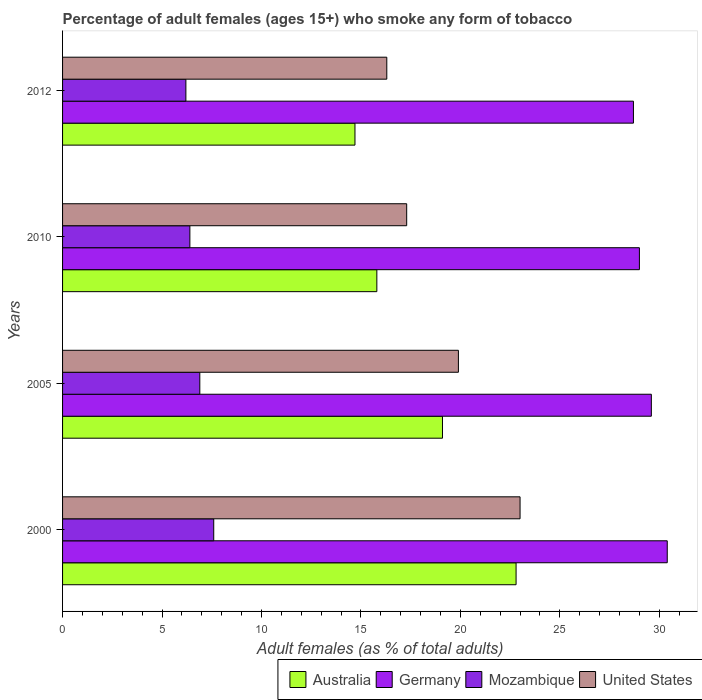How many different coloured bars are there?
Offer a terse response. 4. Are the number of bars per tick equal to the number of legend labels?
Your answer should be compact. Yes. Are the number of bars on each tick of the Y-axis equal?
Ensure brevity in your answer.  Yes. How many bars are there on the 3rd tick from the bottom?
Keep it short and to the point. 4. What is the percentage of adult females who smoke in Australia in 2010?
Give a very brief answer. 15.8. In which year was the percentage of adult females who smoke in Mozambique minimum?
Give a very brief answer. 2012. What is the total percentage of adult females who smoke in Germany in the graph?
Your answer should be very brief. 117.7. What is the difference between the percentage of adult females who smoke in Mozambique in 2005 and that in 2010?
Keep it short and to the point. 0.5. What is the difference between the percentage of adult females who smoke in United States in 2005 and the percentage of adult females who smoke in Germany in 2000?
Provide a short and direct response. -10.5. What is the average percentage of adult females who smoke in Germany per year?
Provide a succinct answer. 29.43. In the year 2005, what is the difference between the percentage of adult females who smoke in Australia and percentage of adult females who smoke in Mozambique?
Provide a short and direct response. 12.2. In how many years, is the percentage of adult females who smoke in Australia greater than 8 %?
Offer a very short reply. 4. What is the ratio of the percentage of adult females who smoke in Australia in 2005 to that in 2010?
Offer a very short reply. 1.21. Is the percentage of adult females who smoke in Australia in 2000 less than that in 2010?
Ensure brevity in your answer.  No. Is the difference between the percentage of adult females who smoke in Australia in 2010 and 2012 greater than the difference between the percentage of adult females who smoke in Mozambique in 2010 and 2012?
Keep it short and to the point. Yes. What is the difference between the highest and the second highest percentage of adult females who smoke in Mozambique?
Make the answer very short. 0.7. What is the difference between the highest and the lowest percentage of adult females who smoke in United States?
Provide a short and direct response. 6.7. In how many years, is the percentage of adult females who smoke in Mozambique greater than the average percentage of adult females who smoke in Mozambique taken over all years?
Provide a succinct answer. 2. Is the sum of the percentage of adult females who smoke in Mozambique in 2000 and 2005 greater than the maximum percentage of adult females who smoke in United States across all years?
Give a very brief answer. No. What does the 1st bar from the top in 2005 represents?
Give a very brief answer. United States. What does the 3rd bar from the bottom in 2012 represents?
Give a very brief answer. Mozambique. What is the difference between two consecutive major ticks on the X-axis?
Ensure brevity in your answer.  5. Does the graph contain any zero values?
Offer a terse response. No. Does the graph contain grids?
Provide a succinct answer. No. How many legend labels are there?
Offer a terse response. 4. How are the legend labels stacked?
Your answer should be compact. Horizontal. What is the title of the graph?
Offer a very short reply. Percentage of adult females (ages 15+) who smoke any form of tobacco. Does "Heavily indebted poor countries" appear as one of the legend labels in the graph?
Your response must be concise. No. What is the label or title of the X-axis?
Your answer should be compact. Adult females (as % of total adults). What is the Adult females (as % of total adults) of Australia in 2000?
Give a very brief answer. 22.8. What is the Adult females (as % of total adults) of Germany in 2000?
Keep it short and to the point. 30.4. What is the Adult females (as % of total adults) of United States in 2000?
Provide a short and direct response. 23. What is the Adult females (as % of total adults) in Germany in 2005?
Offer a terse response. 29.6. What is the Adult females (as % of total adults) in United States in 2005?
Offer a very short reply. 19.9. What is the Adult females (as % of total adults) in Germany in 2010?
Your answer should be very brief. 29. What is the Adult females (as % of total adults) of Germany in 2012?
Your answer should be very brief. 28.7. What is the Adult females (as % of total adults) in United States in 2012?
Provide a succinct answer. 16.3. Across all years, what is the maximum Adult females (as % of total adults) of Australia?
Offer a very short reply. 22.8. Across all years, what is the maximum Adult females (as % of total adults) of Germany?
Offer a very short reply. 30.4. Across all years, what is the minimum Adult females (as % of total adults) of Australia?
Keep it short and to the point. 14.7. Across all years, what is the minimum Adult females (as % of total adults) in Germany?
Ensure brevity in your answer.  28.7. Across all years, what is the minimum Adult females (as % of total adults) in Mozambique?
Your response must be concise. 6.2. What is the total Adult females (as % of total adults) in Australia in the graph?
Give a very brief answer. 72.4. What is the total Adult females (as % of total adults) in Germany in the graph?
Provide a succinct answer. 117.7. What is the total Adult females (as % of total adults) of Mozambique in the graph?
Keep it short and to the point. 27.1. What is the total Adult females (as % of total adults) in United States in the graph?
Offer a terse response. 76.5. What is the difference between the Adult females (as % of total adults) in Australia in 2000 and that in 2005?
Provide a short and direct response. 3.7. What is the difference between the Adult females (as % of total adults) in Mozambique in 2000 and that in 2010?
Your answer should be compact. 1.2. What is the difference between the Adult females (as % of total adults) of Australia in 2000 and that in 2012?
Provide a succinct answer. 8.1. What is the difference between the Adult females (as % of total adults) in Germany in 2000 and that in 2012?
Offer a terse response. 1.7. What is the difference between the Adult females (as % of total adults) in Mozambique in 2000 and that in 2012?
Make the answer very short. 1.4. What is the difference between the Adult females (as % of total adults) of United States in 2000 and that in 2012?
Your answer should be compact. 6.7. What is the difference between the Adult females (as % of total adults) in Germany in 2005 and that in 2010?
Offer a very short reply. 0.6. What is the difference between the Adult females (as % of total adults) of Mozambique in 2005 and that in 2012?
Offer a very short reply. 0.7. What is the difference between the Adult females (as % of total adults) in Australia in 2010 and that in 2012?
Your response must be concise. 1.1. What is the difference between the Adult females (as % of total adults) of United States in 2010 and that in 2012?
Provide a succinct answer. 1. What is the difference between the Adult females (as % of total adults) in Australia in 2000 and the Adult females (as % of total adults) in Germany in 2005?
Ensure brevity in your answer.  -6.8. What is the difference between the Adult females (as % of total adults) of Germany in 2000 and the Adult females (as % of total adults) of Mozambique in 2005?
Your answer should be very brief. 23.5. What is the difference between the Adult females (as % of total adults) in Germany in 2000 and the Adult females (as % of total adults) in United States in 2005?
Your response must be concise. 10.5. What is the difference between the Adult females (as % of total adults) of Australia in 2000 and the Adult females (as % of total adults) of Germany in 2010?
Keep it short and to the point. -6.2. What is the difference between the Adult females (as % of total adults) of Germany in 2000 and the Adult females (as % of total adults) of Mozambique in 2010?
Provide a succinct answer. 24. What is the difference between the Adult females (as % of total adults) of Germany in 2000 and the Adult females (as % of total adults) of Mozambique in 2012?
Give a very brief answer. 24.2. What is the difference between the Adult females (as % of total adults) of Germany in 2000 and the Adult females (as % of total adults) of United States in 2012?
Offer a terse response. 14.1. What is the difference between the Adult females (as % of total adults) of Mozambique in 2000 and the Adult females (as % of total adults) of United States in 2012?
Make the answer very short. -8.7. What is the difference between the Adult females (as % of total adults) in Australia in 2005 and the Adult females (as % of total adults) in Germany in 2010?
Ensure brevity in your answer.  -9.9. What is the difference between the Adult females (as % of total adults) in Australia in 2005 and the Adult females (as % of total adults) in Mozambique in 2010?
Make the answer very short. 12.7. What is the difference between the Adult females (as % of total adults) in Australia in 2005 and the Adult females (as % of total adults) in United States in 2010?
Make the answer very short. 1.8. What is the difference between the Adult females (as % of total adults) of Germany in 2005 and the Adult females (as % of total adults) of Mozambique in 2010?
Your answer should be very brief. 23.2. What is the difference between the Adult females (as % of total adults) in Germany in 2005 and the Adult females (as % of total adults) in United States in 2010?
Give a very brief answer. 12.3. What is the difference between the Adult females (as % of total adults) of Mozambique in 2005 and the Adult females (as % of total adults) of United States in 2010?
Your answer should be compact. -10.4. What is the difference between the Adult females (as % of total adults) in Australia in 2005 and the Adult females (as % of total adults) in United States in 2012?
Ensure brevity in your answer.  2.8. What is the difference between the Adult females (as % of total adults) of Germany in 2005 and the Adult females (as % of total adults) of Mozambique in 2012?
Provide a short and direct response. 23.4. What is the difference between the Adult females (as % of total adults) in Germany in 2005 and the Adult females (as % of total adults) in United States in 2012?
Offer a very short reply. 13.3. What is the difference between the Adult females (as % of total adults) of Australia in 2010 and the Adult females (as % of total adults) of Mozambique in 2012?
Offer a very short reply. 9.6. What is the difference between the Adult females (as % of total adults) of Australia in 2010 and the Adult females (as % of total adults) of United States in 2012?
Give a very brief answer. -0.5. What is the difference between the Adult females (as % of total adults) in Germany in 2010 and the Adult females (as % of total adults) in Mozambique in 2012?
Make the answer very short. 22.8. What is the difference between the Adult females (as % of total adults) in Germany in 2010 and the Adult females (as % of total adults) in United States in 2012?
Keep it short and to the point. 12.7. What is the average Adult females (as % of total adults) in Germany per year?
Offer a very short reply. 29.43. What is the average Adult females (as % of total adults) of Mozambique per year?
Offer a terse response. 6.78. What is the average Adult females (as % of total adults) of United States per year?
Give a very brief answer. 19.12. In the year 2000, what is the difference between the Adult females (as % of total adults) in Australia and Adult females (as % of total adults) in Germany?
Ensure brevity in your answer.  -7.6. In the year 2000, what is the difference between the Adult females (as % of total adults) in Germany and Adult females (as % of total adults) in Mozambique?
Give a very brief answer. 22.8. In the year 2000, what is the difference between the Adult females (as % of total adults) in Germany and Adult females (as % of total adults) in United States?
Make the answer very short. 7.4. In the year 2000, what is the difference between the Adult females (as % of total adults) of Mozambique and Adult females (as % of total adults) of United States?
Offer a terse response. -15.4. In the year 2005, what is the difference between the Adult females (as % of total adults) of Germany and Adult females (as % of total adults) of Mozambique?
Your response must be concise. 22.7. In the year 2005, what is the difference between the Adult females (as % of total adults) in Germany and Adult females (as % of total adults) in United States?
Keep it short and to the point. 9.7. In the year 2010, what is the difference between the Adult females (as % of total adults) of Australia and Adult females (as % of total adults) of Mozambique?
Your response must be concise. 9.4. In the year 2010, what is the difference between the Adult females (as % of total adults) in Germany and Adult females (as % of total adults) in Mozambique?
Ensure brevity in your answer.  22.6. In the year 2010, what is the difference between the Adult females (as % of total adults) of Germany and Adult females (as % of total adults) of United States?
Keep it short and to the point. 11.7. In the year 2012, what is the difference between the Adult females (as % of total adults) in Australia and Adult females (as % of total adults) in Mozambique?
Your answer should be compact. 8.5. What is the ratio of the Adult females (as % of total adults) of Australia in 2000 to that in 2005?
Offer a very short reply. 1.19. What is the ratio of the Adult females (as % of total adults) of Mozambique in 2000 to that in 2005?
Offer a very short reply. 1.1. What is the ratio of the Adult females (as % of total adults) in United States in 2000 to that in 2005?
Offer a very short reply. 1.16. What is the ratio of the Adult females (as % of total adults) in Australia in 2000 to that in 2010?
Offer a very short reply. 1.44. What is the ratio of the Adult females (as % of total adults) in Germany in 2000 to that in 2010?
Provide a short and direct response. 1.05. What is the ratio of the Adult females (as % of total adults) in Mozambique in 2000 to that in 2010?
Offer a terse response. 1.19. What is the ratio of the Adult females (as % of total adults) of United States in 2000 to that in 2010?
Your answer should be very brief. 1.33. What is the ratio of the Adult females (as % of total adults) of Australia in 2000 to that in 2012?
Your answer should be compact. 1.55. What is the ratio of the Adult females (as % of total adults) in Germany in 2000 to that in 2012?
Your answer should be very brief. 1.06. What is the ratio of the Adult females (as % of total adults) of Mozambique in 2000 to that in 2012?
Make the answer very short. 1.23. What is the ratio of the Adult females (as % of total adults) of United States in 2000 to that in 2012?
Offer a very short reply. 1.41. What is the ratio of the Adult females (as % of total adults) of Australia in 2005 to that in 2010?
Ensure brevity in your answer.  1.21. What is the ratio of the Adult females (as % of total adults) in Germany in 2005 to that in 2010?
Your response must be concise. 1.02. What is the ratio of the Adult females (as % of total adults) in Mozambique in 2005 to that in 2010?
Your answer should be very brief. 1.08. What is the ratio of the Adult females (as % of total adults) in United States in 2005 to that in 2010?
Give a very brief answer. 1.15. What is the ratio of the Adult females (as % of total adults) in Australia in 2005 to that in 2012?
Make the answer very short. 1.3. What is the ratio of the Adult females (as % of total adults) of Germany in 2005 to that in 2012?
Offer a terse response. 1.03. What is the ratio of the Adult females (as % of total adults) of Mozambique in 2005 to that in 2012?
Provide a short and direct response. 1.11. What is the ratio of the Adult females (as % of total adults) in United States in 2005 to that in 2012?
Your answer should be compact. 1.22. What is the ratio of the Adult females (as % of total adults) of Australia in 2010 to that in 2012?
Keep it short and to the point. 1.07. What is the ratio of the Adult females (as % of total adults) of Germany in 2010 to that in 2012?
Your answer should be compact. 1.01. What is the ratio of the Adult females (as % of total adults) of Mozambique in 2010 to that in 2012?
Give a very brief answer. 1.03. What is the ratio of the Adult females (as % of total adults) of United States in 2010 to that in 2012?
Keep it short and to the point. 1.06. What is the difference between the highest and the second highest Adult females (as % of total adults) of Australia?
Your answer should be compact. 3.7. What is the difference between the highest and the second highest Adult females (as % of total adults) of Mozambique?
Offer a very short reply. 0.7. What is the difference between the highest and the lowest Adult females (as % of total adults) in Mozambique?
Offer a terse response. 1.4. What is the difference between the highest and the lowest Adult females (as % of total adults) of United States?
Provide a short and direct response. 6.7. 